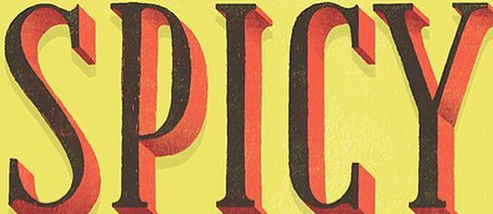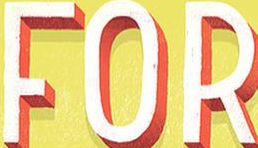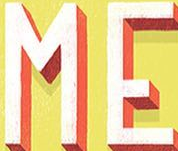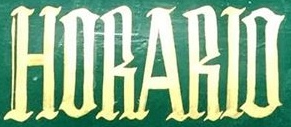Read the text from these images in sequence, separated by a semicolon. SPICY; FOR; ME; HORARIO 